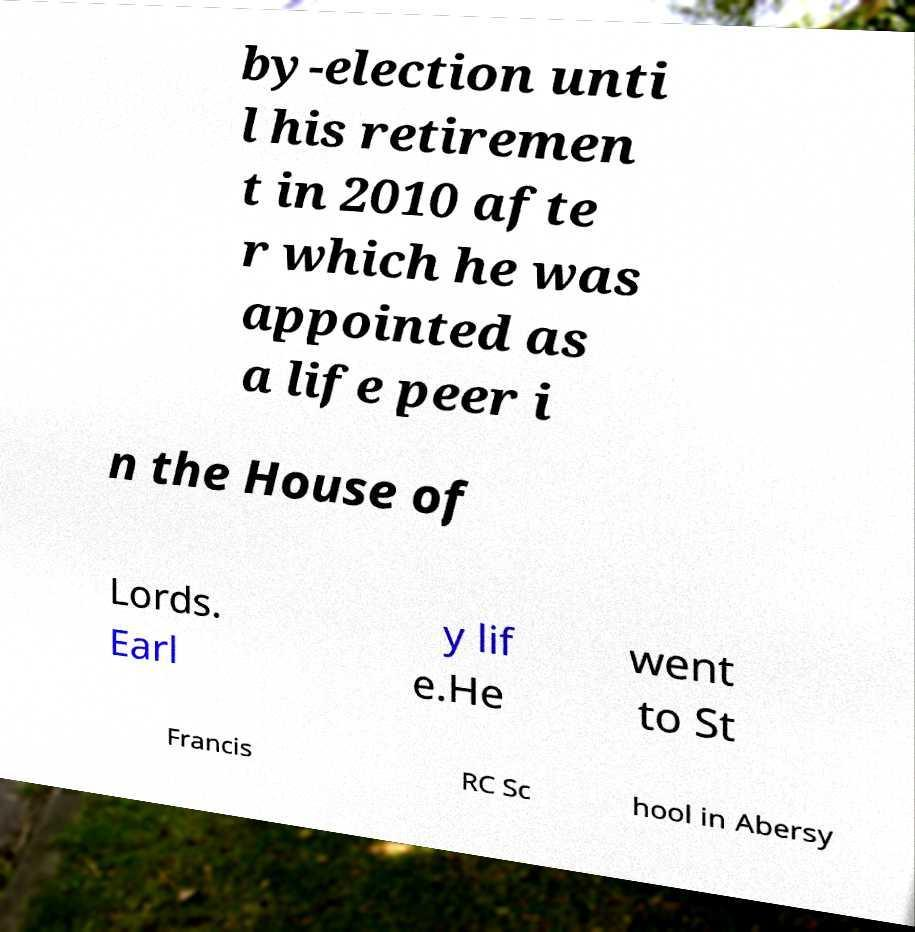Please identify and transcribe the text found in this image. by-election unti l his retiremen t in 2010 afte r which he was appointed as a life peer i n the House of Lords. Earl y lif e.He went to St Francis RC Sc hool in Abersy 